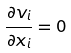<formula> <loc_0><loc_0><loc_500><loc_500>\frac { \partial v _ { i } } { \partial x _ { i } } = 0</formula> 